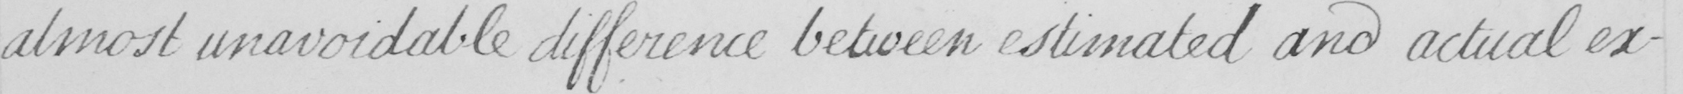Transcribe the text shown in this historical manuscript line. almost unavoidable difference between estimated and actual ex- 